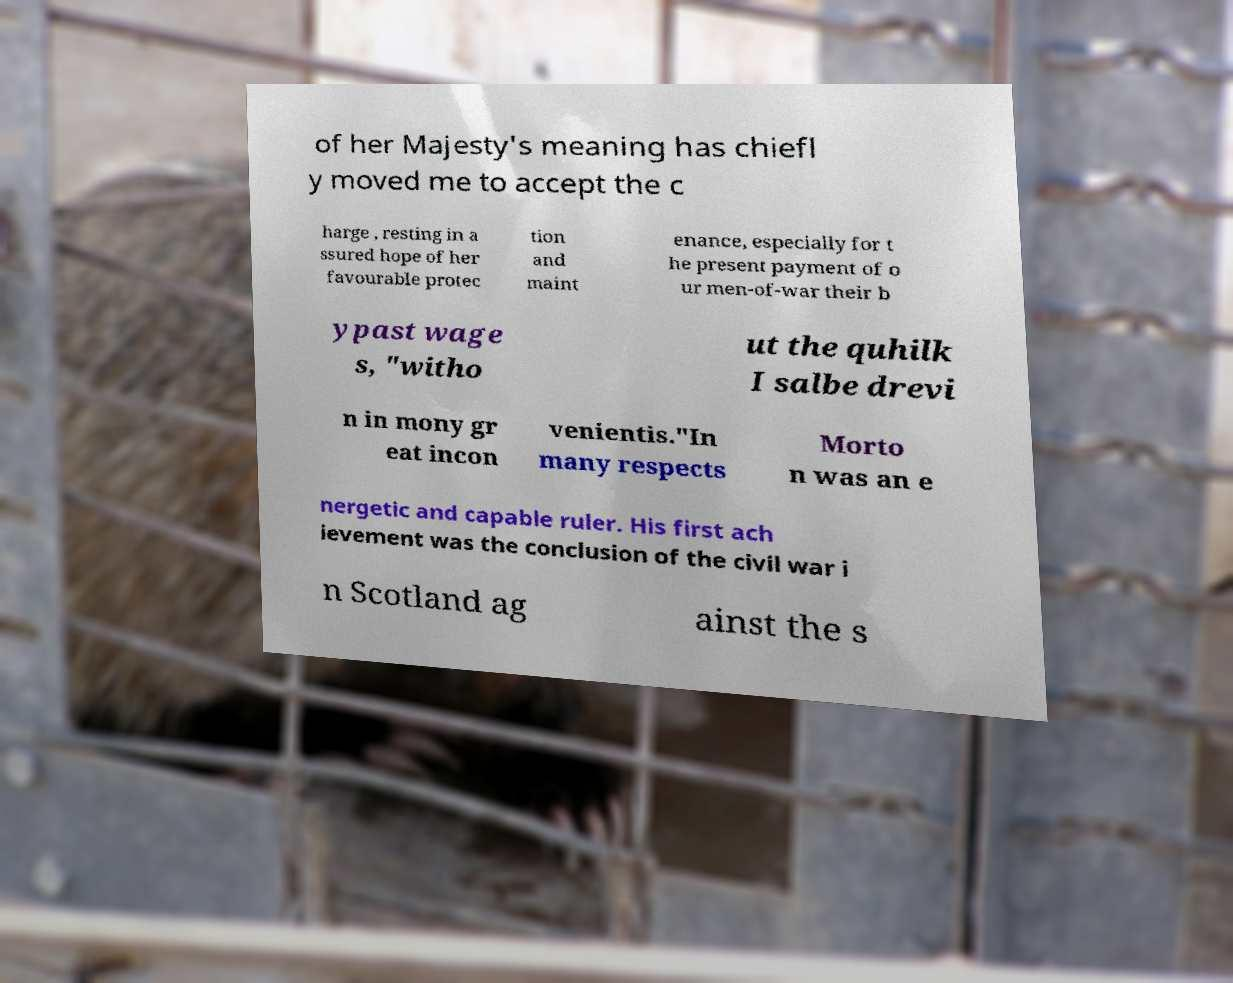Can you accurately transcribe the text from the provided image for me? of her Majesty's meaning has chiefl y moved me to accept the c harge , resting in a ssured hope of her favourable protec tion and maint enance, especially for t he present payment of o ur men-of-war their b ypast wage s, "witho ut the quhilk I salbe drevi n in mony gr eat incon venientis."In many respects Morto n was an e nergetic and capable ruler. His first ach ievement was the conclusion of the civil war i n Scotland ag ainst the s 